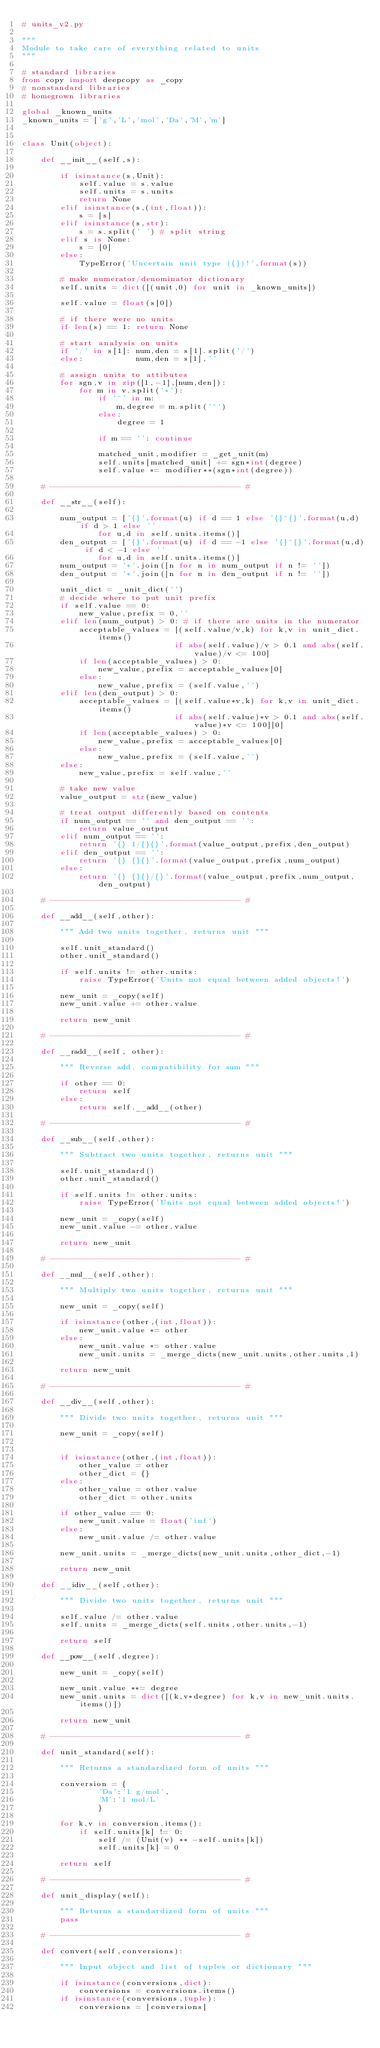Convert code to text. <code><loc_0><loc_0><loc_500><loc_500><_Python_># units_v2.py

"""
Module to take care of everything related to units
"""

# standard libraries
from copy import deepcopy as _copy 
# nonstandard libraries
# homegrown libraries

global _known_units
_known_units = ['g','L','mol','Da','M','m']


class Unit(object):

    def __init__(self,s):

        if isinstance(s,Unit):
            self.value = s.value
            self.units = s.units
            return None
        elif isinstance(s,(int,float)):
            s = [s]
        elif isinstance(s,str):
            s = s.split(' ') # split string
        elif s is None:
            s = [0]
        else:
            TypeError('Uncertain unit type ({})!'.format(s))

        # make numerator/denominator dictionary
        self.units = dict([(unit,0) for unit in _known_units])

        self.value = float(s[0])
    
        # if there were no units
        if len(s) == 1: return None
            
        # start analysis on units 
        if '/' in s[1]: num,den = s[1].split('/')
        else:           num,den = s[1],''

        # assign units to attibutes
        for sgn,v in zip([1,-1],[num,den]):
            for m in v.split('*'):
                if '^' in m:
                    m,degree = m.split('^')
                else:
                    degree = 1

                if m == '': continue

                matched_unit,modifier = _get_unit(m)
                self.units[matched_unit] += sgn*int(degree)
                self.value *= modifier**(sgn*int(degree))

    # ---------------------------------------- #

    def __str__(self):

        num_output = ['{}'.format(u) if d == 1 else '{}^{}'.format(u,d) if d > 1 else ''
                for u,d in self.units.items()]
        den_output = ['{}'.format(u) if d == -1 else '{}^{}'.format(u,d) if d < -1 else ''
                for u,d in self.units.items()]
        num_output = '*'.join([n for n in num_output if n != ''])
        den_output = '*'.join([n for n in den_output if n != ''])

        unit_dict = _unit_dict('')
        # decide where to put unit prefix
        if self.value == 0:
            new_value,prefix = 0,''
        elif len(num_output) > 0: # if there are units in the numerator
            acceptable_values = [(self.value/v,k) for k,v in unit_dict.items() 
                                if abs(self.value)/v > 0.1 and abs(self.value)/v <= 100]
            if len(acceptable_values) > 0:
                new_value,prefix = acceptable_values[0]
            else:
                new_value,prefix = (self.value,'')
        elif len(den_output) > 0:
            acceptable_values = [(self.value*v,k) for k,v in unit_dict.items() 
                                if abs(self.value)*v > 0.1 and abs(self.value)*v <= 100][0]
            if len(acceptable_values) > 0:
                new_value,prefix = acceptable_values[0]
            else:
                new_value,prefix = (self.value,'')
        else:
            new_value,prefix = self.value,''

        # take new value
        value_output = str(new_value)
        
        # treat output differently based on contents
        if num_output == '' and den_output == '':
            return value_output
        elif num_output == '':
            return '{} 1/{}{}'.format(value_output,prefix,den_output)
        elif den_output == '':
            return '{} {}{}'.format(value_output,prefix,num_output)
        else:
            return '{} {}{}/{}'.format(value_output,prefix,num_output,den_output)

    # ---------------------------------------- #

    def __add__(self,other):

        """ Add two units together, returns unit """

        self.unit_standard()
        other.unit_standard()

        if self.units != other.units:
            raise TypeError('Units not equal between added objects!')
       
        new_unit = _copy(self)
        new_unit.value += other.value

        return new_unit 

    # ---------------------------------------- #

    def __radd__(self, other):

        """ Reverse add, compatibility for sum """

        if other == 0:
            return self
        else:
            return self.__add__(other)

    # ---------------------------------------- #

    def __sub__(self,other):

        """ Subtract two units together, returns unit """

        self.unit_standard()
        other.unit_standard()

        if self.units != other.units:
            raise TypeError('Units not equal between added objects!')

        new_unit = _copy(self)
        new_unit.value -= other.value

        return new_unit 

    # ---------------------------------------- #

    def __mul__(self,other):

        """ Multiply two units together, returns unit """

        new_unit = _copy(self)
        
        if isinstance(other,(int,float)):
            new_unit.value *= other
        else:
            new_unit.value *= other.value
            new_unit.units = _merge_dicts(new_unit.units,other.units,1)

        return new_unit 

    # ---------------------------------------- #

    def __div__(self,other):

        """ Divide two units together, returns unit """

        new_unit = _copy(self)


        if isinstance(other,(int,float)):
            other_value = other
            other_dict = {}
        else:
            other_value = other.value
            other_dict = other.units

        if other_value == 0:
            new_unit.value = float('inf')
        else:    
            new_unit.value /= other.value

        new_unit.units = _merge_dicts(new_unit.units,other_dict,-1)

        return new_unit 

    def __idiv__(self,other):

        """ Divide two units together, returns unit """

        self.value /= other.value
        self.units = _merge_dicts(self.units,other.units,-1)

        return self

    def __pow__(self,degree):

        new_unit = _copy(self)

        new_unit.value **= degree
        new_unit.units = dict([(k,v*degree) for k,v in new_unit.units.items()])

        return new_unit 

    # ---------------------------------------- #

    def unit_standard(self):

        """ Returns a standardized form of units """

        conversion = {
                'Da':'1 g/mol',
                'M':'1 mol/L'
                }

        for k,v in conversion.items():
            if self.units[k] != 0:
                self /= (Unit(v) ** -self.units[k])
                self.units[k] = 0

        return self 

    # ---------------------------------------- #

    def unit_display(self):

        """ Returns a standardized form of units """
        pass

    # ---------------------------------------- #

    def convert(self,conversions):

        """ Input object and list of tuples or dictionary """

        if isinstance(conversions,dict):
            conversions = conversions.items() 
        if isinstance(conversions,tuple):
            conversions = [conversions]
</code> 